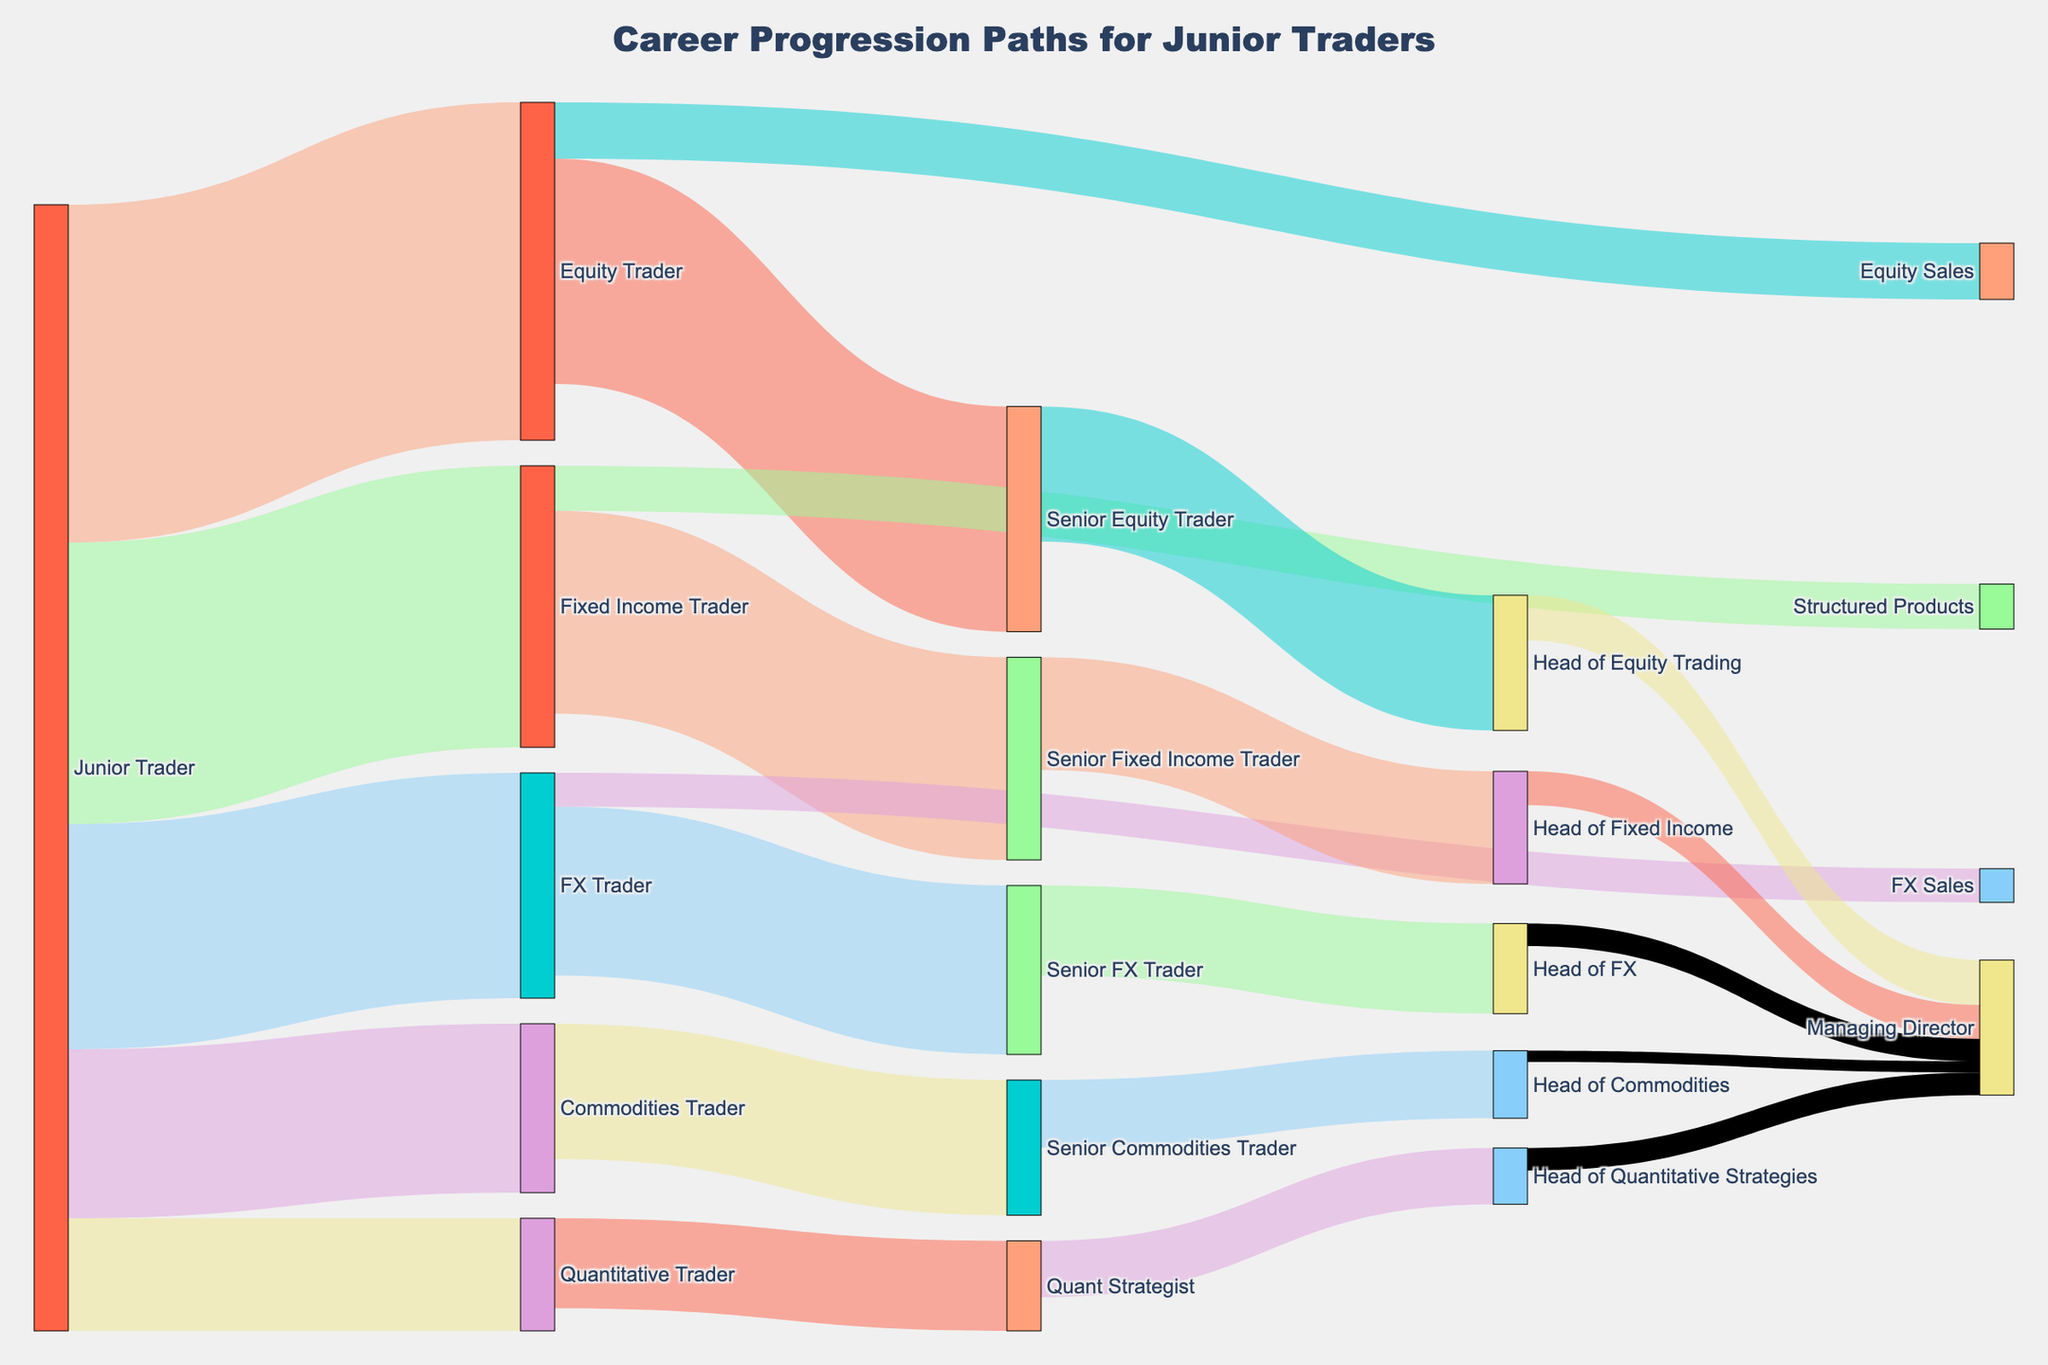What's the title of the figure? The title is typically found at the top of the figure. In this case, it is "Career Progression Paths for Junior Traders".
Answer: Career Progression Paths for Junior Traders How many junior traders transitioned to becoming Quantitative Traders? Look at the link connecting "Junior Trader" to "Quantitative Trader" and observe the value associated with that link.
Answer: 10 Which target role has the highest number of transitions from Junior Trader? Compare the values of the different targets from "Junior Trader". The one with the highest value will be the answer.
Answer: Equity Trader How many individuals progressed to Managing Director? Sum the values of links connecting to "Managing Director" from various Head positions. Specifically, add 4 (Head of Equity Trading) + 3 (Head of Fixed Income) + 2 (Head of FX) + 1 (Head of Commodities) + 2 (Head of Quantitative Strategies).
Answer: 12 Which Senior level trading position sees the highest transition to a Head position? Compare the values of the links from each senior trading position to their respective head positions: Senior Equity Trader (12), Senior Fixed Income Trader (10), Senior FX Trader (8), Senior Commodities Trader (6). The one with the highest value indicates the answer.
Answer: Senior Equity Trader From the total number of Equity Traders, how many did not advance to Senior Equity Trader? Subtract the number of Equity Traders advancing to Senior Equity Trader from the total number of Equity Traders. The total is 30, and 20 advanced to Senior Equity Trader. So, 30 - 20 = 10.
Answer: 10 How does the transition to Managing Director compare between Heads of Equity Trading and Heads of Fixed Income? The number from Head of Equity Trading to Managing Director is 4, while from Head of Fixed Income to Managing Director is 3.
Answer: Managing Director from Head of Equity Trading is greater by 1 What's the total number of traders starting as Junior Traders in the diagram? Sum all the values originating from "Junior Trader": 30 (Equity Trader) + 25 (Fixed Income Trader) + 20 (FX Trader) + 15 (Commodities Trader) + 10 (Quantitative Trader) to get the total.
Answer: 100 How many Quantitative Traders moved to become Head of Quantitative Strategies? Look at the value of the link from "Quant Strategist" to "Head of Quantitative Strategies".
Answer: 5 What is the ratio of Junior Traders transitioning to senior roles in the FX department versus those transitioning to senior roles in the Commodities department? Count the values: FX (15 Senior FX Trader + 3 FX Sales = 18), Commodities (12 Senior Commodities Trader). The ratio is 18:12 or simplified to 3:2.
Answer: 3:2 